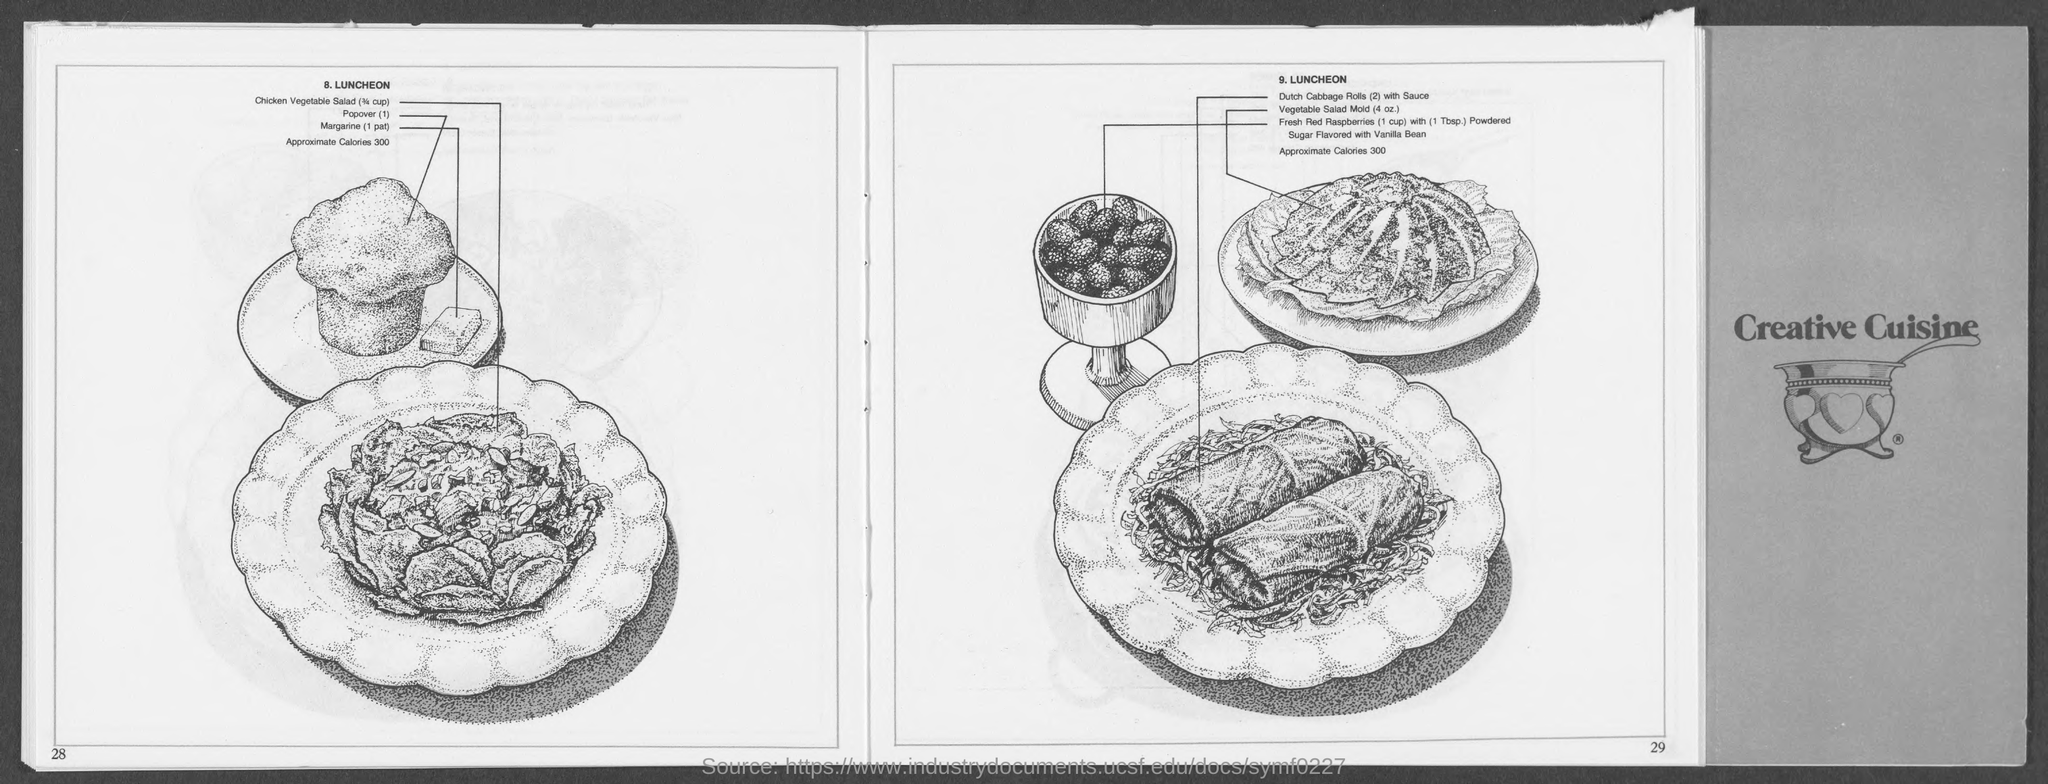List a handful of essential elements in this visual. The third dish on the menu for lunch at 8.LUNCHEON is margarine (1 pat). 